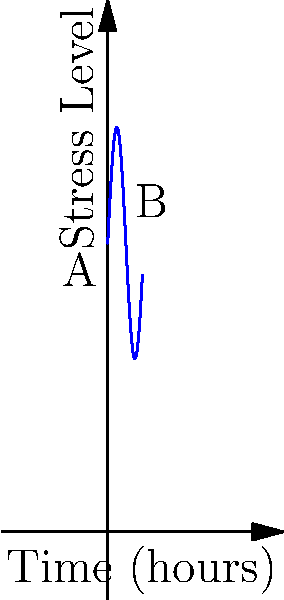The graph shows the stress levels of a night shift worker over a 6-hour period. If the stress level is given by the function $S(t) = 50 + 20\sin(t)$, where $t$ is time in hours, calculate the instantaneous rate of change in stress level at point B (3 hours into the shift). To find the instantaneous rate of change at point B, we need to calculate the derivative of the stress function $S(t)$ at $t=3$. 

Step 1: Find the derivative of $S(t)$
$$\frac{d}{dt}S(t) = \frac{d}{dt}(50 + 20\sin(t)) = 20\cos(t)$$

Step 2: Evaluate the derivative at $t=3$
$$\frac{dS}{dt}\bigg|_{t=3} = 20\cos(3)$$

Step 3: Calculate the value
$$20\cos(3) \approx 20 \cdot (-0.9899) \approx -19.798$$

The negative value indicates that the stress level is decreasing at this point.
Answer: $-19.798$ units/hour 